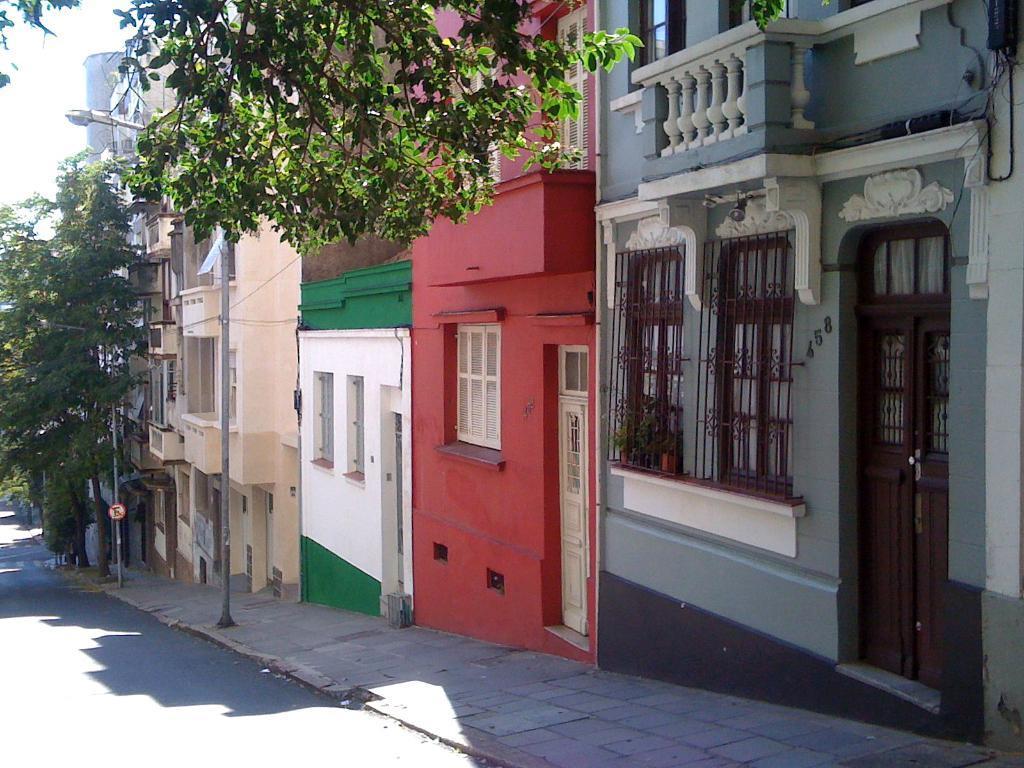How would you summarize this image in a sentence or two? At the bottom on the left side we can see road. In the background there are trees, boards on the poles, buildings, windows, doors, objects on the wall and sky. 